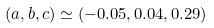Convert formula to latex. <formula><loc_0><loc_0><loc_500><loc_500>( a , b , c ) \simeq ( - 0 . 0 5 , 0 . 0 4 , 0 . 2 9 )</formula> 